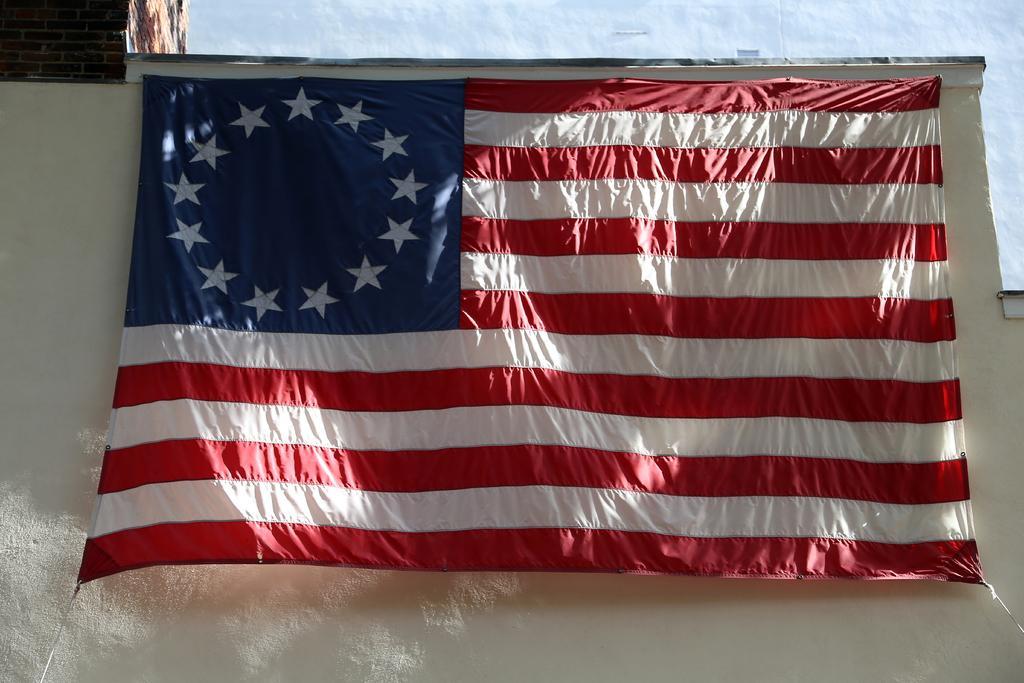Can you describe this image briefly? In this image I can see a flag in red, blue and white color and the background is in white color. 